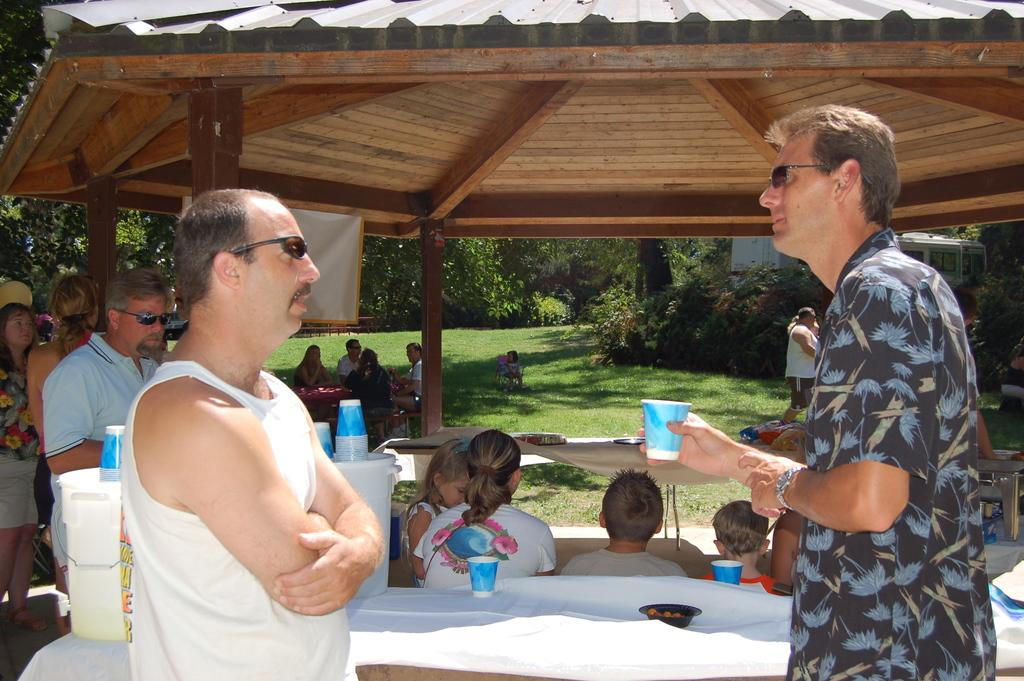What are the people in the image doing? The people in the image are sitting in the grass. What can be seen in the background of the image? There are trees in the image. What is the man holding in the image? The man is holding a glass. Are there any people standing in the image? Yes, there are people standing in the image. What objects can be seen in addition to the people? There are buckets present in the image. What type of poison is the man drinking from the glass in the image? There is no poison present in the image; the man is holding a glass, but its contents are not specified. 